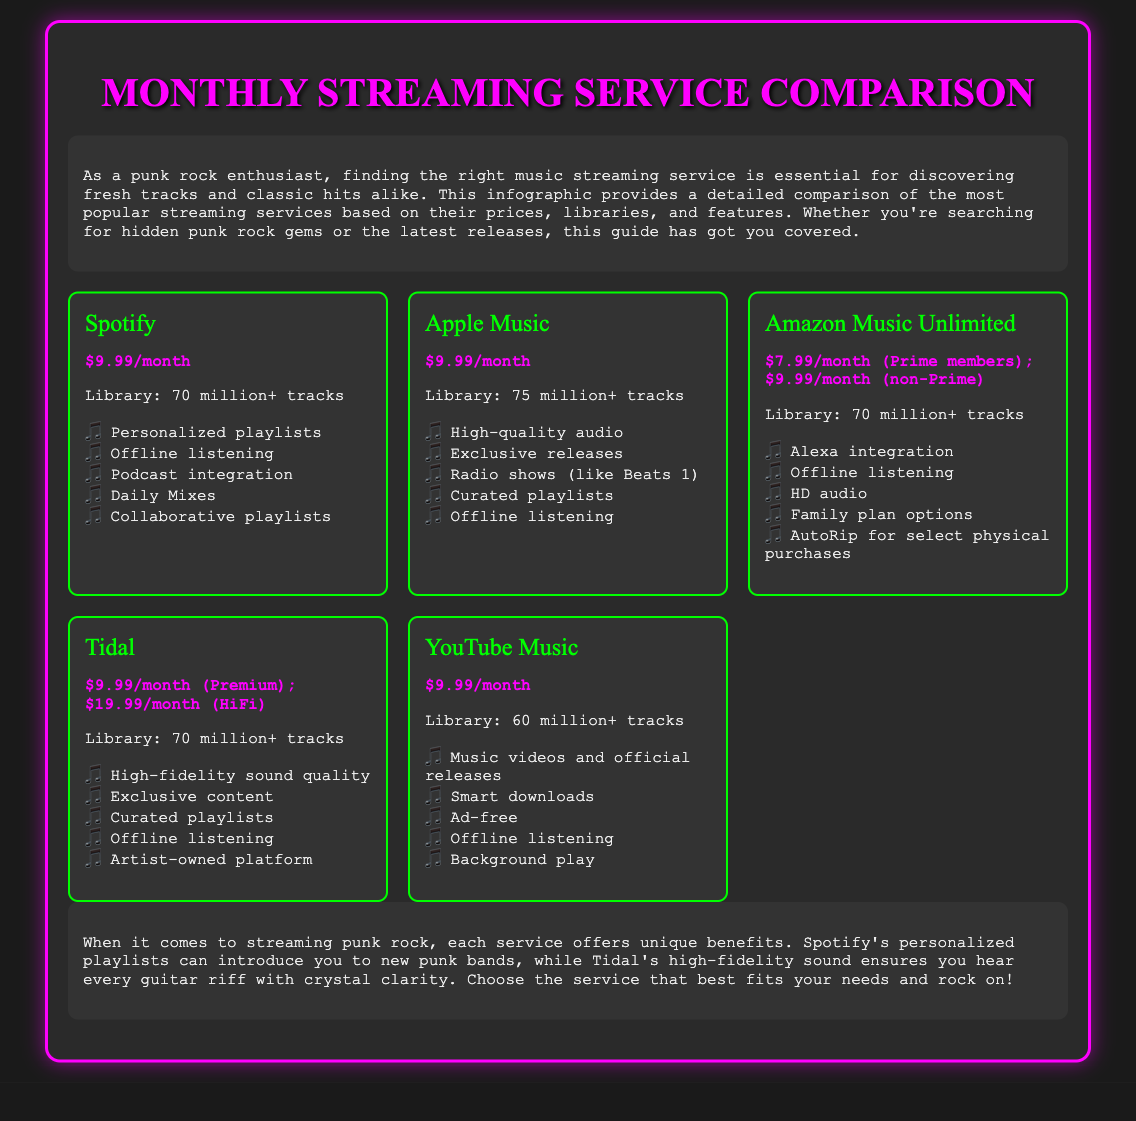What is the genre focus of the infographic? The infographic is designed for punk rock enthusiasts, highlighting services for discovering tracks in that genre.
Answer: Punk rock How many tracks does Apple Music offer? The document states that Apple Music has a library of 75 million+ tracks.
Answer: 75 million+ What is the price of Amazon Music Unlimited for non-Prime members? The price listed for non-Prime members is $9.99/month according to the document.
Answer: $9.99/month Which streaming service is known for high-fidelity sound quality? The document specifies that Tidal offers high-fidelity sound quality among its features.
Answer: Tidal What feature does Spotify offer for discovering new music? The document mentions that Spotify provides personalized playlists to help users discover new music.
Answer: Personalized playlists What is the difference in price between Tidal's Premium and HiFi plans? The document indicates the difference in price is $10, with Premium at $9.99/month and HiFi at $19.99/month.
Answer: $10 How many tracks does YouTube Music have compared to other services? YouTube Music has a library of 60 million+ tracks, which is the smallest compared to others.
Answer: 60 million+ What exclusive feature is specific to Tidal? Tidal is described as an artist-owned platform, which is a unique aspect mentioned in the document.
Answer: Artist-owned platform What is the common price among most of the streaming services listed? Most of the streaming services, except Amazon Music Unlimited for non-Prime and Tidal HiFi, share a price of $9.99/month.
Answer: $9.99/month 